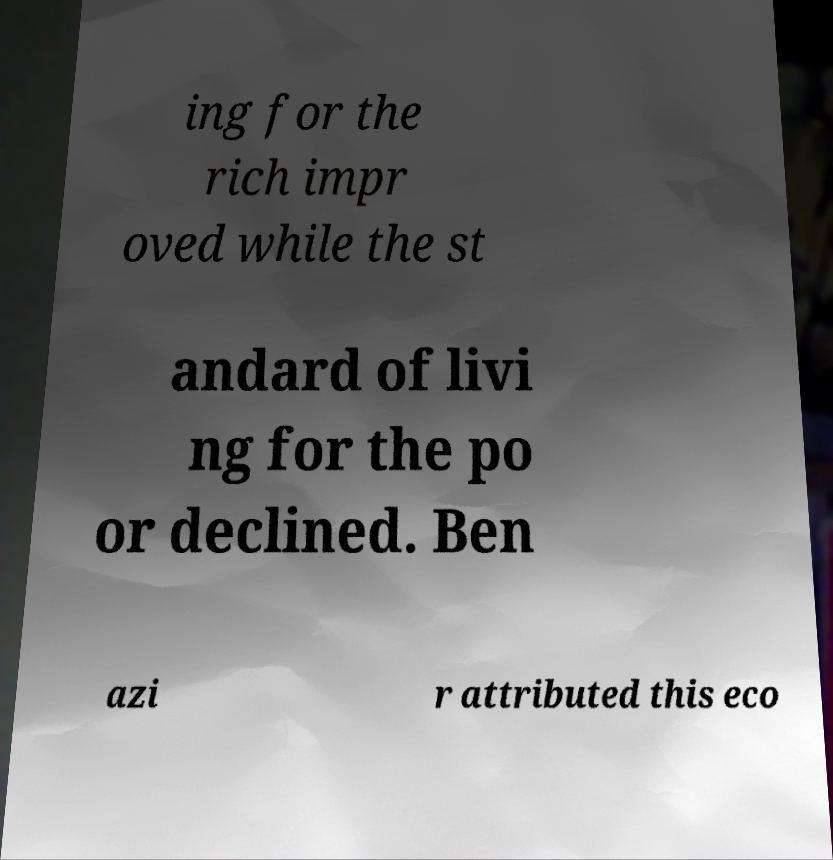Can you accurately transcribe the text from the provided image for me? ing for the rich impr oved while the st andard of livi ng for the po or declined. Ben azi r attributed this eco 